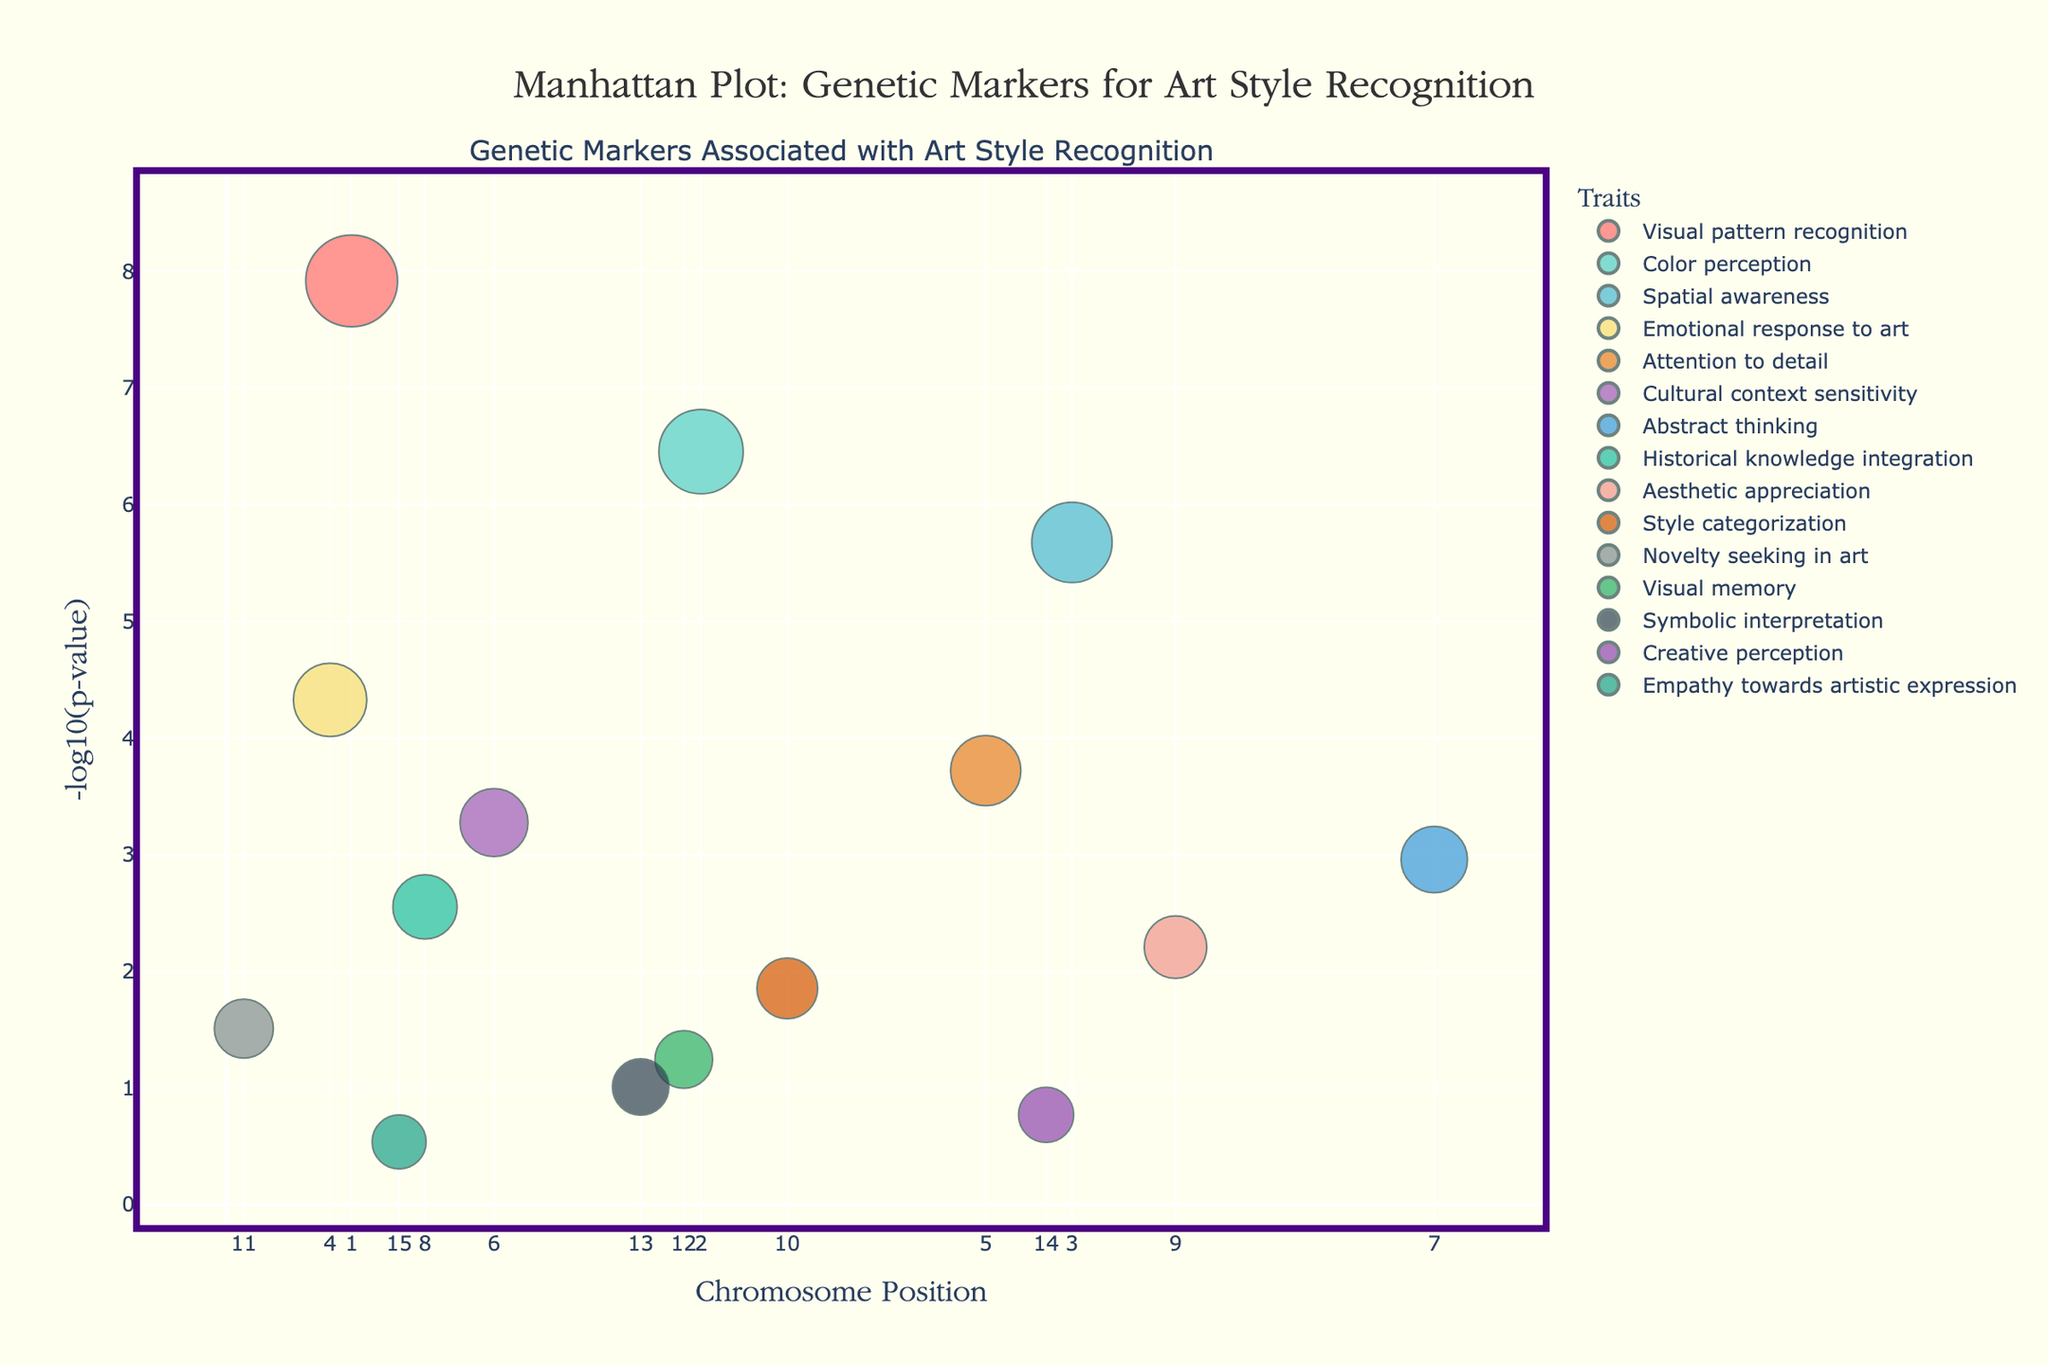What's the title of the plot? The title is typically found at the top of the plot. In this case, it reads "Manhattan Plot: Genetic Markers for Art Style Recognition".
Answer: Manhattan Plot: Genetic Markers for Art Style Recognition What trait is associated with the most significant genetic marker? The most significant genetic marker corresponds to the lowest p-value, which translates to the highest -log10(p-value). From the plot, it is clear that the genetic marker with the highest -log10(p-value) is associated with "Visual pattern recognition".
Answer: Visual pattern recognition How many traits are represented in the plot? Each color in the plot corresponds to a different trait. By counting the number of unique colors in the legend, we can determine the number of traits. According to the legend, there are 15 different colored traits in the figure.
Answer: 15 Which chromosome has the highest number of significant markers? The number of significant markers on a chromosome can be assessed by counting the number of data points on the x-axis that correspond to each unique chromosome number. Chromosome 1 has the highest number with 1 significant marker labeled "FOXP2" for the trait "Visual pattern recognition".
Answer: Chromosome 1 What is the p-value threshold used to determine significance in the plot? The significance threshold is typically p < 5 x 10^-8. Data points above this threshold are not considered significant. Thus, genetic markers with -log10(p-values) less than approximately 7.3 are considered significant. The plot shows markers mostly above -log10(p-values) = 7.
Answer: 5 x 10^-8 Which trait has markers on the highest and lowest chromosome positions? The highest and lowest chromosome positions marking traits are represented by their genomic positions on the x-axis. The "Abstract thinking" trait (CHRNA7) is on chromosome 7 at position 140,000,000, the highest position, and the "Selective attention" trait (FOXP2) on chromosome 1 at position 14,500,000 is among the lowest.
Answer: Abstract thinking (highest) and Selective attention (lowest) Which marker is directly tied to cultural context sensitivity, and what is its approximate position? For cultural context sensitivity, the marker corresponds to chromosome 6. According to the plot, marker HLA-DRB1, which is at approximately 31,000,000 as the position on chromosome 6, is linked to cultural context sensitivity.
Answer: HLA-DRB1 at 31,000,000 Which two traits are associated with markers located closest to each other? To find traits with markers closest to each other, look for the smallest distance between two points on the x-axis. Markers for "Visual Memory" and "Symbolic Interpretation" are closest to each other with positions at 53,000,000 and 48,000,000, respectively, on chromosomes 12 and 13.
Answer: Visual Memory and Symbolic Interpretation What trait is associated with the smallest marker size and its corresponding position? The smallest marker size indicates the least significant trait among the ones plotted. "Empathy towards artistic expression" (OXTR) has the smallest marker size and is located at position 20,000,000 on chromosome 15.
Answer: Empathy towards artistic expression at 20,000,000 